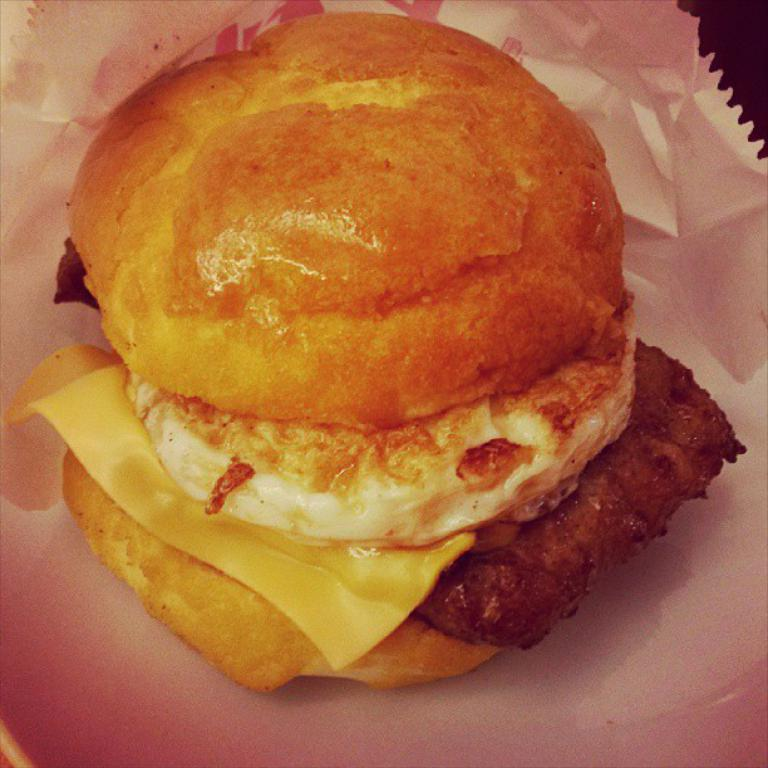What type of food is visible in the image? There is a burger in the image. What is the burger placed on? The burger is on a paper. Can you describe any other objects or features in the image? There is a table in the top right corner of the image. How long does the flight take in the image? There is no flight or any indication of time in the image; it only features a burger on a paper and a table in the top right corner. 